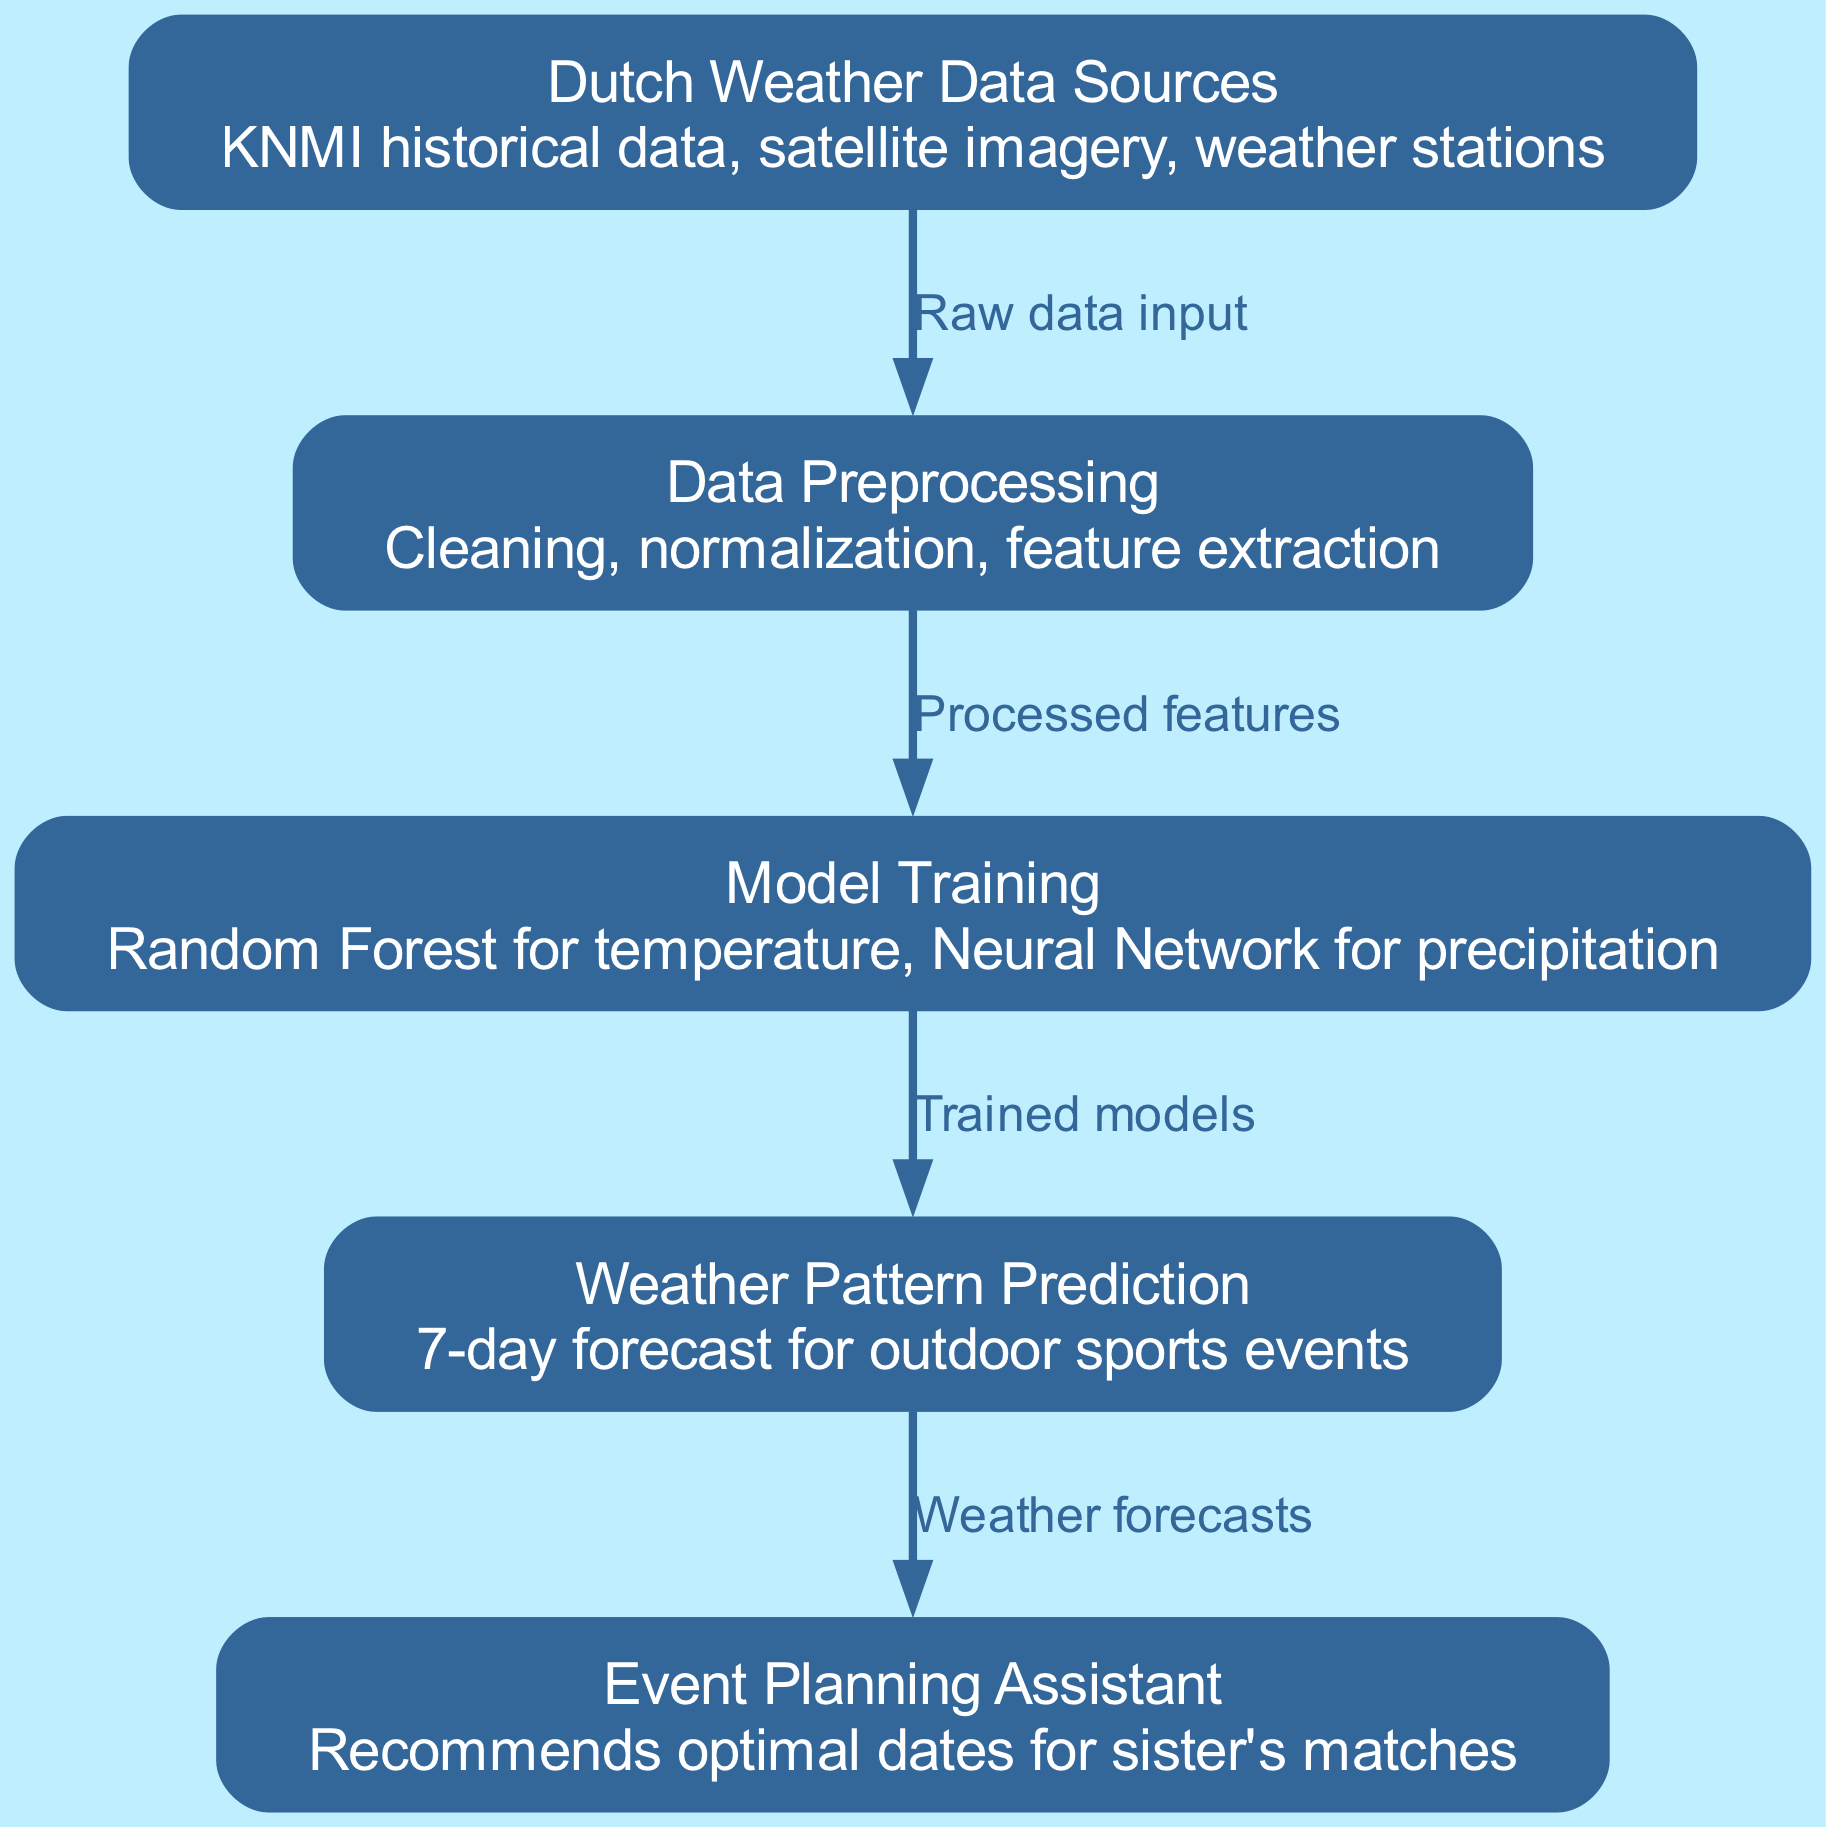What are the sources of weather data? The diagram lists "KNMI historical data, satellite imagery, weather stations" as the sources of weather data, which are directly provided in the node labeled "Dutch Weather Data Sources."
Answer: KNMI historical data, satellite imagery, weather stations How many nodes are in the diagram? By counting the elements labeled as nodes, we find there are five nodes: Dutch Weather Data Sources, Data Preprocessing, Model Training, Weather Pattern Prediction, and Event Planning Assistant.
Answer: 5 What is the last step in the pipeline? The last node in the pipeline is labeled "Event Planning Assistant," indicating that this is the final step after weather pattern predictions have been made.
Answer: Event Planning Assistant Which model is used for temperature prediction? The node labeled "Model Training" specifies that a "Random Forest" model is used specifically for temperature predictions.
Answer: Random Forest What do the processed features lead to? The edge labeled "Processed features" indicates that these processed features from "Data Preprocessing" lead to the next node, which is "Model Training."
Answer: Model Training What type of weather prediction is generated? The node "Weather Pattern Prediction" states that it generates a "7-day forecast for outdoor sports events," indicating the type of prediction produced.
Answer: 7-day forecast Which component inputs raw data into the pipeline? The diagram shows the first node labeled "Dutch Weather Data Sources," which takes raw data as an input to the next step, "Data Preprocessing."
Answer: Dutch Weather Data Sources What models are trained in the "Model Training" step? The "Model Training" node describes that it trains a "Random Forest for temperature" and a "Neural Network for precipitation," specifying the models used for each type of weather component.
Answer: Random Forest, Neural Network What does the Event Planning Assistant do? The "Event Planning Assistant" node indicates that it "recommends optimal dates for sister's matches," showing the purpose of this component in the pipeline.
Answer: Recommends optimal dates for sister's matches 